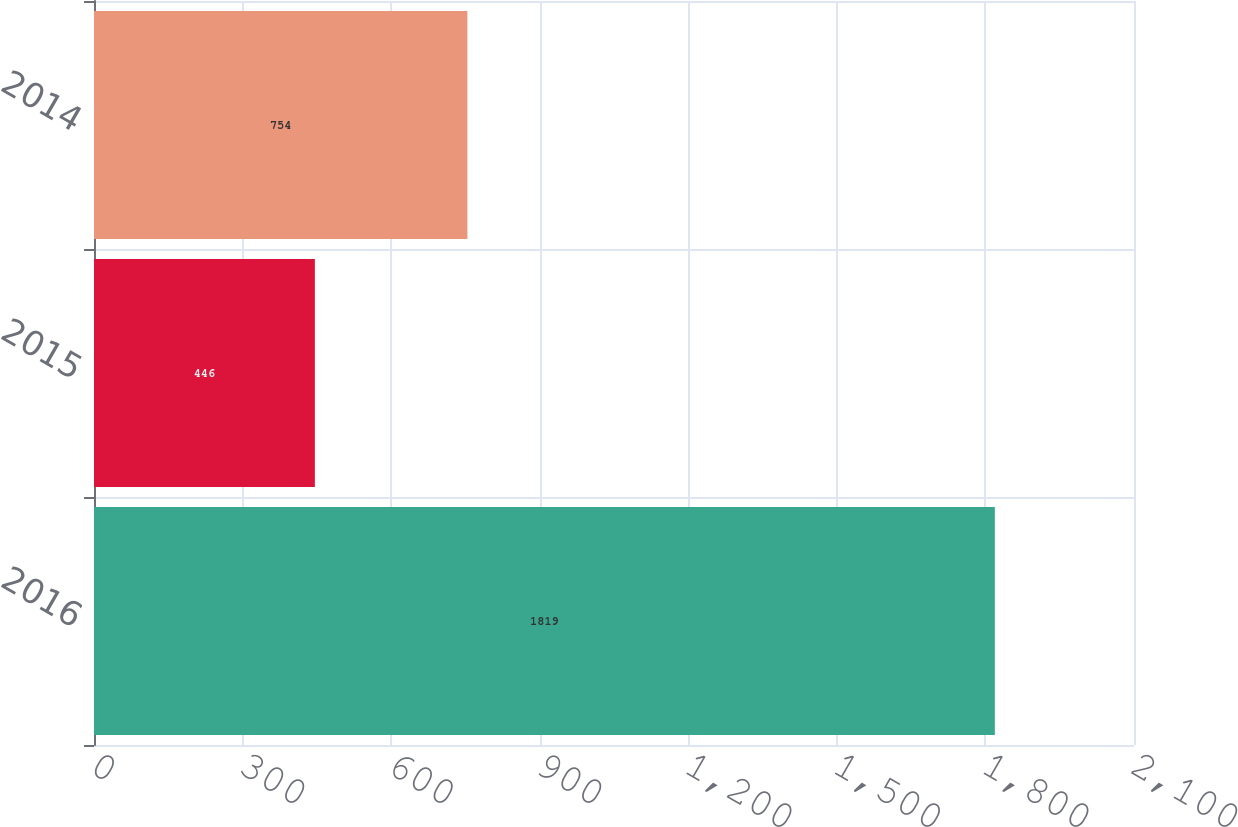Convert chart. <chart><loc_0><loc_0><loc_500><loc_500><bar_chart><fcel>2016<fcel>2015<fcel>2014<nl><fcel>1819<fcel>446<fcel>754<nl></chart> 